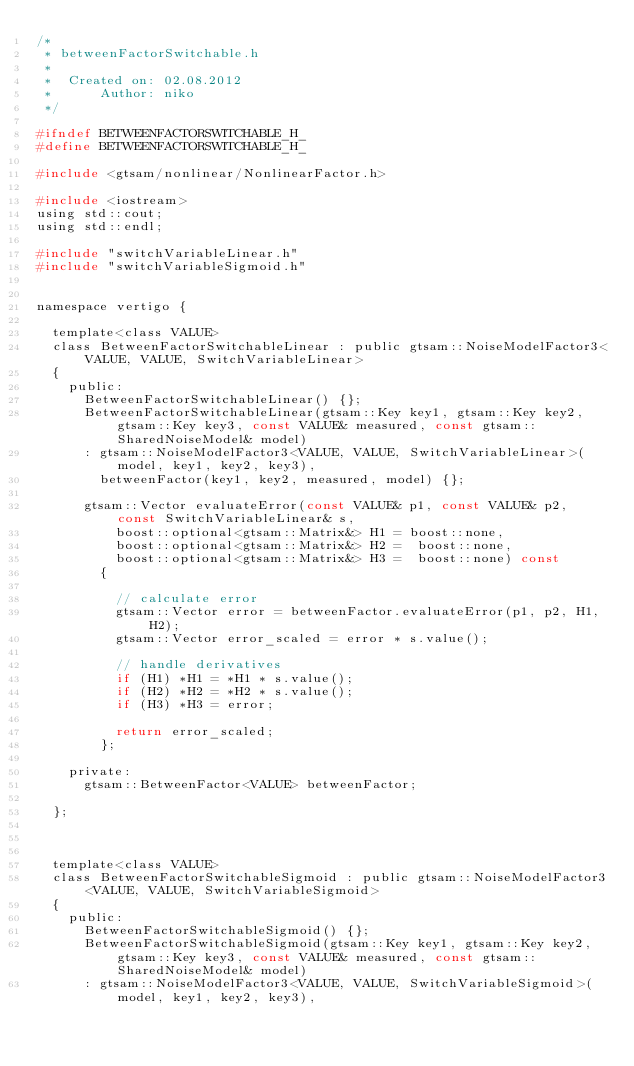<code> <loc_0><loc_0><loc_500><loc_500><_C_>/*
 * betweenFactorSwitchable.h
 *
 *  Created on: 02.08.2012
 *      Author: niko
 */

#ifndef BETWEENFACTORSWITCHABLE_H_
#define BETWEENFACTORSWITCHABLE_H_

#include <gtsam/nonlinear/NonlinearFactor.h>

#include <iostream>
using std::cout;
using std::endl;

#include "switchVariableLinear.h"
#include "switchVariableSigmoid.h"


namespace vertigo {

  template<class VALUE>
  class BetweenFactorSwitchableLinear : public gtsam::NoiseModelFactor3<VALUE, VALUE, SwitchVariableLinear>
  {
    public:
      BetweenFactorSwitchableLinear() {};
      BetweenFactorSwitchableLinear(gtsam::Key key1, gtsam::Key key2, gtsam::Key key3, const VALUE& measured, const gtsam::SharedNoiseModel& model)
      : gtsam::NoiseModelFactor3<VALUE, VALUE, SwitchVariableLinear>(model, key1, key2, key3),
        betweenFactor(key1, key2, measured, model) {};

      gtsam::Vector evaluateError(const VALUE& p1, const VALUE& p2, const SwitchVariableLinear& s,
          boost::optional<gtsam::Matrix&> H1 = boost::none,
          boost::optional<gtsam::Matrix&> H2 =  boost::none,
          boost::optional<gtsam::Matrix&> H3 =  boost::none) const
        {

          // calculate error
          gtsam::Vector error = betweenFactor.evaluateError(p1, p2, H1, H2);
          gtsam::Vector error_scaled = error * s.value();

          // handle derivatives
          if (H1) *H1 = *H1 * s.value();
          if (H2) *H2 = *H2 * s.value();
          if (H3) *H3 = error;

          return error_scaled;
        };

    private:
      gtsam::BetweenFactor<VALUE> betweenFactor;

  };



  template<class VALUE>
  class BetweenFactorSwitchableSigmoid : public gtsam::NoiseModelFactor3<VALUE, VALUE, SwitchVariableSigmoid>
  {
    public:
      BetweenFactorSwitchableSigmoid() {};
      BetweenFactorSwitchableSigmoid(gtsam::Key key1, gtsam::Key key2, gtsam::Key key3, const VALUE& measured, const gtsam::SharedNoiseModel& model)
      : gtsam::NoiseModelFactor3<VALUE, VALUE, SwitchVariableSigmoid>(model, key1, key2, key3),</code> 